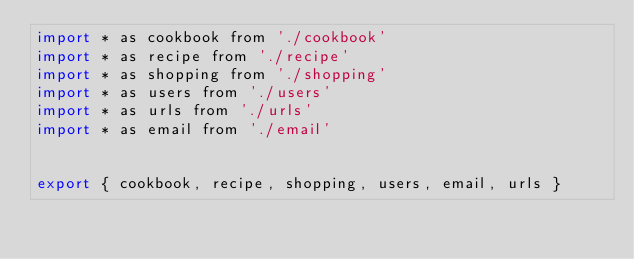Convert code to text. <code><loc_0><loc_0><loc_500><loc_500><_JavaScript_>import * as cookbook from './cookbook'
import * as recipe from './recipe'
import * as shopping from './shopping'
import * as users from './users'
import * as urls from './urls'
import * as email from './email'


export { cookbook, recipe, shopping, users, email, urls }
</code> 